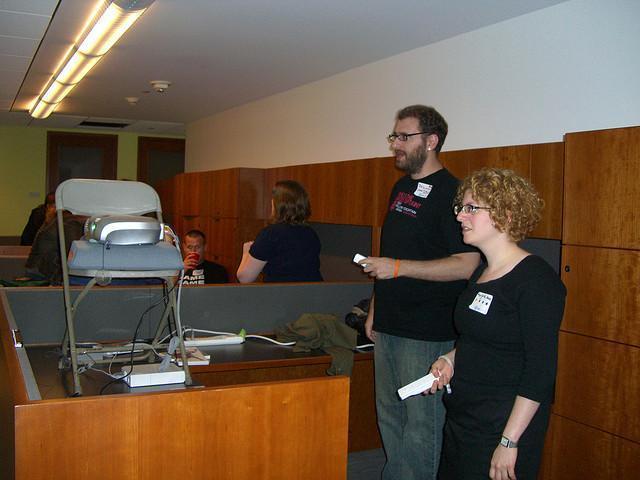What kind of label is on their shirts?
From the following four choices, select the correct answer to address the question.
Options: Warning, instructional, brand, name tag. Name tag. 